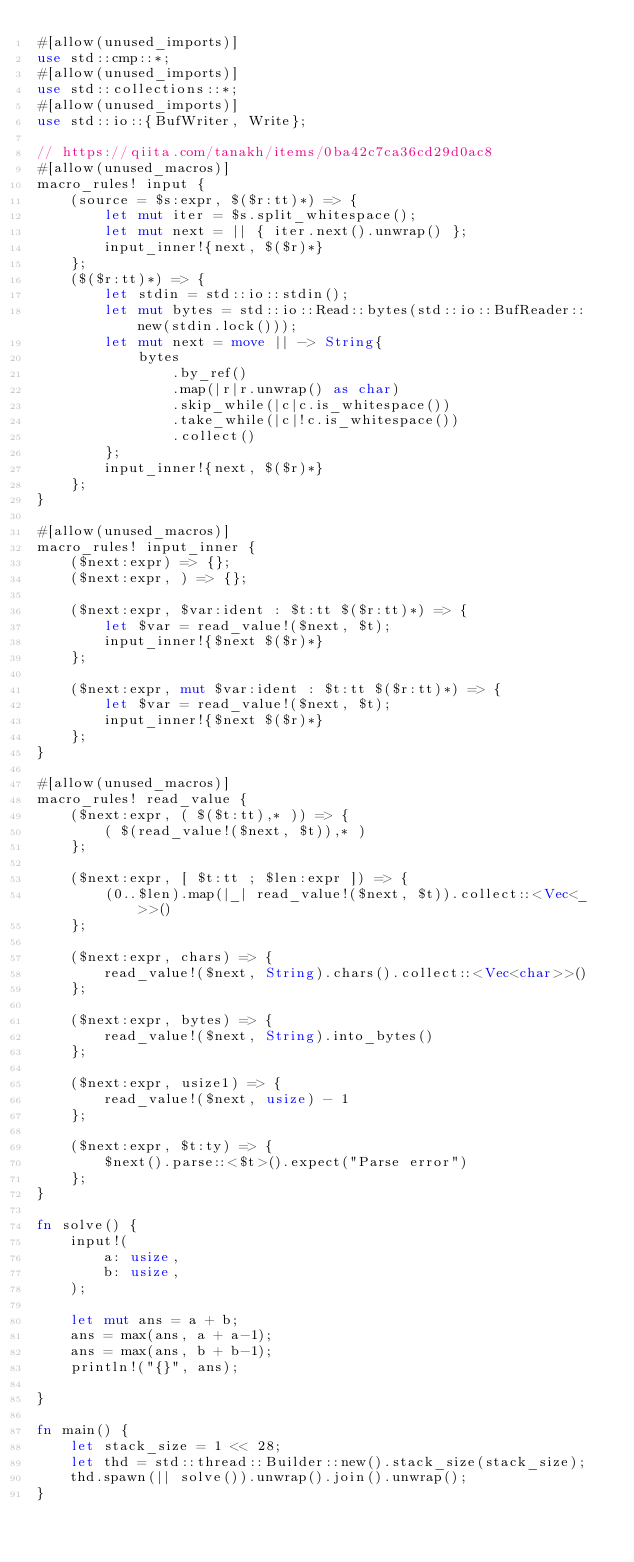<code> <loc_0><loc_0><loc_500><loc_500><_Rust_>#[allow(unused_imports)]
use std::cmp::*;
#[allow(unused_imports)]
use std::collections::*;
#[allow(unused_imports)]
use std::io::{BufWriter, Write};

// https://qiita.com/tanakh/items/0ba42c7ca36cd29d0ac8
#[allow(unused_macros)]
macro_rules! input {
    (source = $s:expr, $($r:tt)*) => {
        let mut iter = $s.split_whitespace();
        let mut next = || { iter.next().unwrap() };
        input_inner!{next, $($r)*}
    };
    ($($r:tt)*) => {
        let stdin = std::io::stdin();
        let mut bytes = std::io::Read::bytes(std::io::BufReader::new(stdin.lock()));
        let mut next = move || -> String{
            bytes
                .by_ref()
                .map(|r|r.unwrap() as char)
                .skip_while(|c|c.is_whitespace())
                .take_while(|c|!c.is_whitespace())
                .collect()
        };
        input_inner!{next, $($r)*}
    };
}

#[allow(unused_macros)]
macro_rules! input_inner {
    ($next:expr) => {};
    ($next:expr, ) => {};

    ($next:expr, $var:ident : $t:tt $($r:tt)*) => {
        let $var = read_value!($next, $t);
        input_inner!{$next $($r)*}
    };

    ($next:expr, mut $var:ident : $t:tt $($r:tt)*) => {
        let $var = read_value!($next, $t);
        input_inner!{$next $($r)*}
    };
}

#[allow(unused_macros)]
macro_rules! read_value {
    ($next:expr, ( $($t:tt),* )) => {
        ( $(read_value!($next, $t)),* )
    };

    ($next:expr, [ $t:tt ; $len:expr ]) => {
        (0..$len).map(|_| read_value!($next, $t)).collect::<Vec<_>>()
    };

    ($next:expr, chars) => {
        read_value!($next, String).chars().collect::<Vec<char>>()
    };

    ($next:expr, bytes) => {
        read_value!($next, String).into_bytes()
    };

    ($next:expr, usize1) => {
        read_value!($next, usize) - 1
    };

    ($next:expr, $t:ty) => {
        $next().parse::<$t>().expect("Parse error")
    };
}

fn solve() {
    input!(
        a: usize,
        b: usize,
    );

    let mut ans = a + b;
    ans = max(ans, a + a-1);
    ans = max(ans, b + b-1);
    println!("{}", ans);

}

fn main() {
    let stack_size = 1 << 28;
    let thd = std::thread::Builder::new().stack_size(stack_size);
    thd.spawn(|| solve()).unwrap().join().unwrap();
}
</code> 